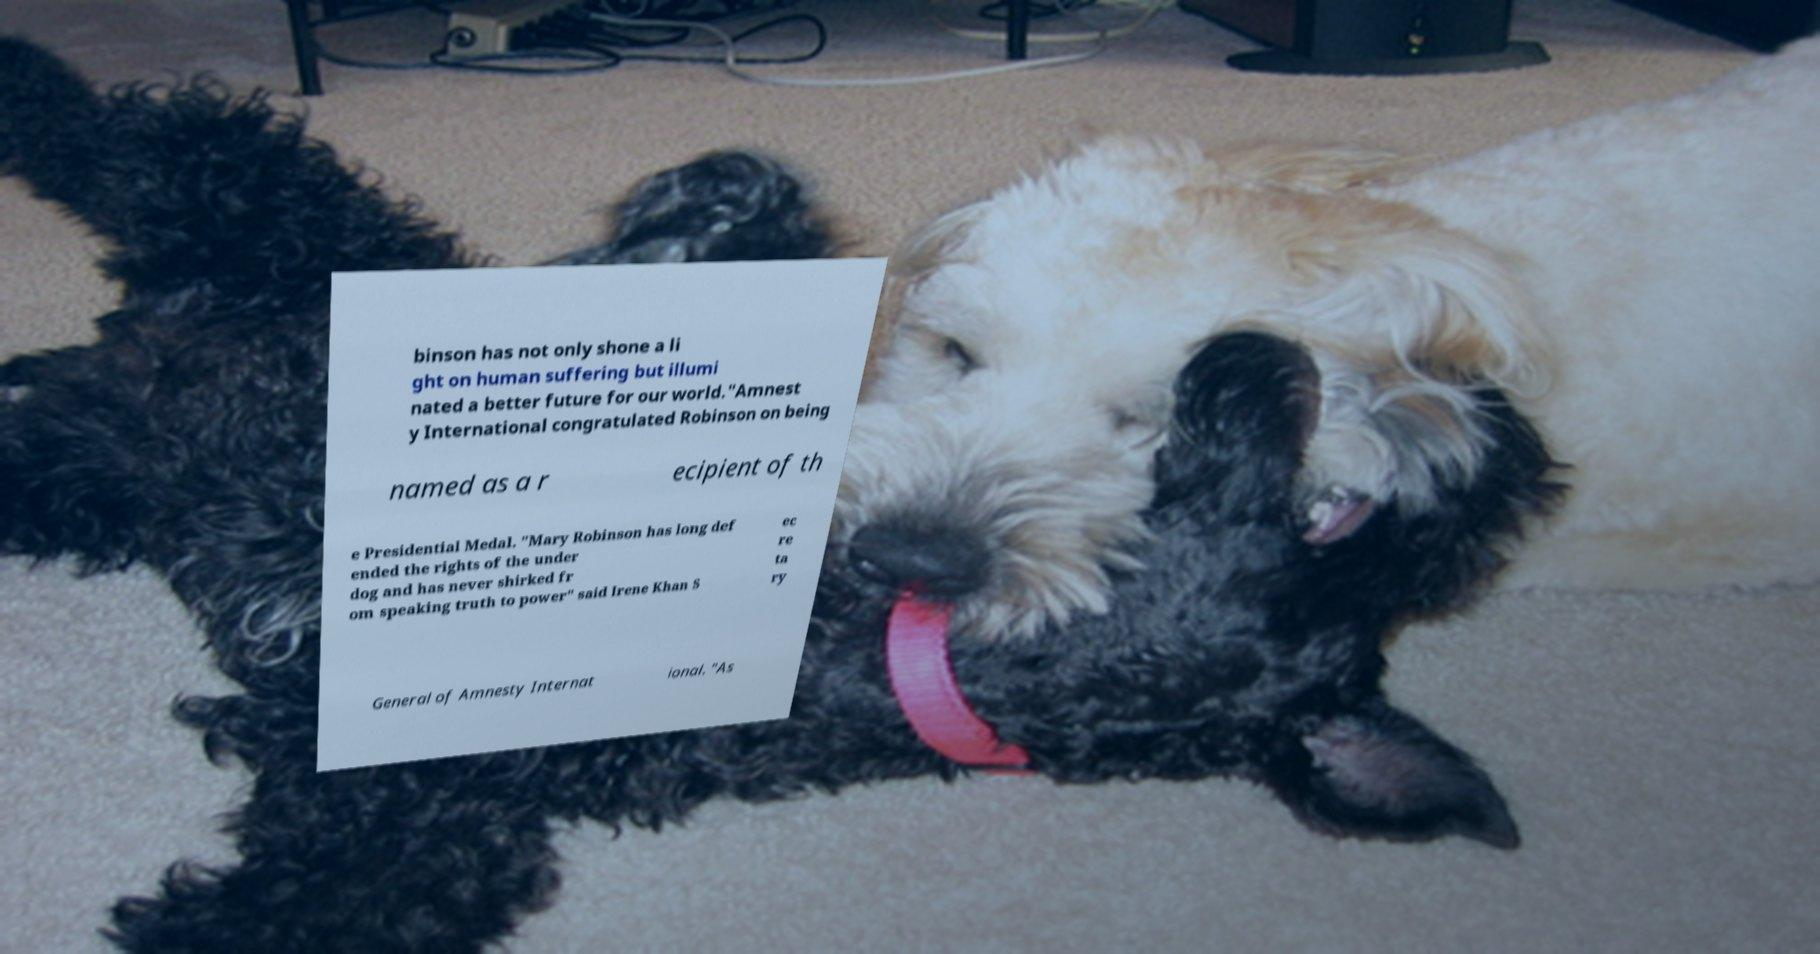Please read and relay the text visible in this image. What does it say? binson has not only shone a li ght on human suffering but illumi nated a better future for our world."Amnest y International congratulated Robinson on being named as a r ecipient of th e Presidential Medal. "Mary Robinson has long def ended the rights of the under dog and has never shirked fr om speaking truth to power" said Irene Khan S ec re ta ry General of Amnesty Internat ional. "As 